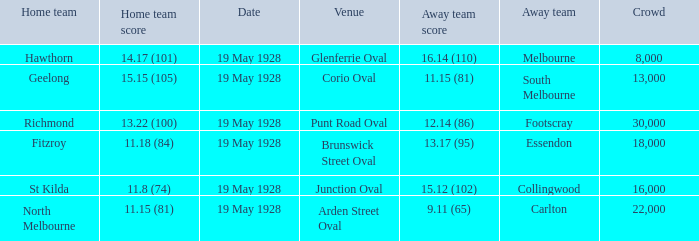What venue featured a crowd of over 30,000? None. 